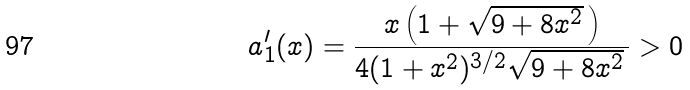Convert formula to latex. <formula><loc_0><loc_0><loc_500><loc_500>a _ { 1 } ^ { \prime } ( x ) = \frac { x \left ( 1 + \sqrt { 9 + 8 x ^ { 2 } } \, \right ) } { 4 ( 1 + x ^ { 2 } ) ^ { 3 / 2 } \sqrt { 9 + 8 x ^ { 2 } } \, } > 0</formula> 